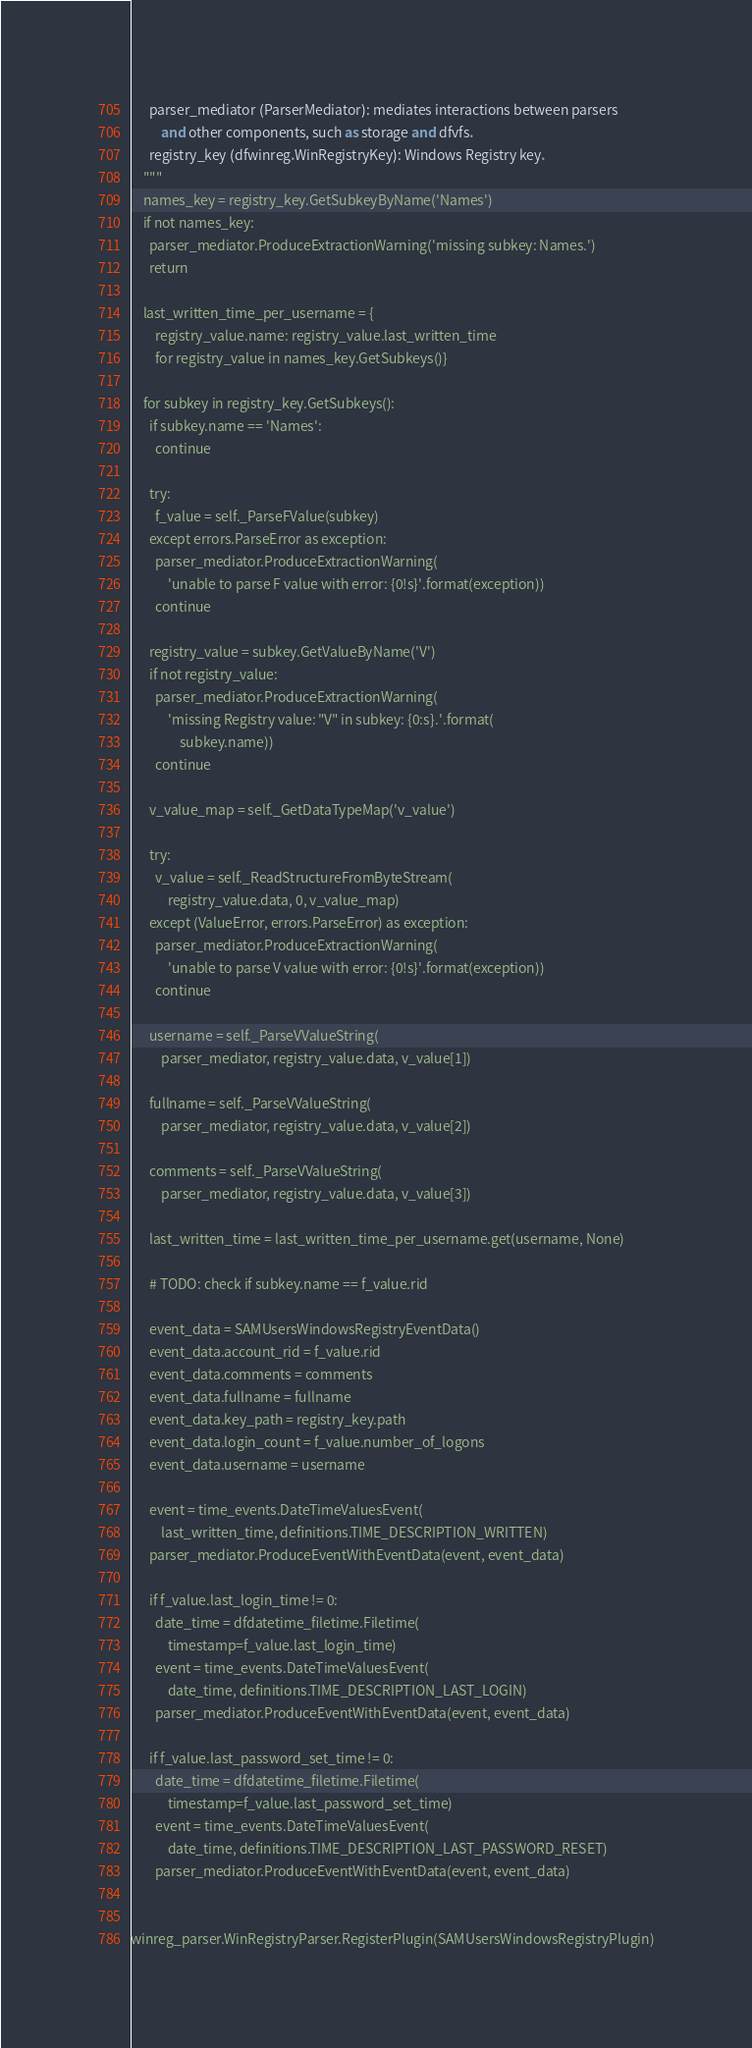<code> <loc_0><loc_0><loc_500><loc_500><_Python_>      parser_mediator (ParserMediator): mediates interactions between parsers
          and other components, such as storage and dfvfs.
      registry_key (dfwinreg.WinRegistryKey): Windows Registry key.
    """
    names_key = registry_key.GetSubkeyByName('Names')
    if not names_key:
      parser_mediator.ProduceExtractionWarning('missing subkey: Names.')
      return

    last_written_time_per_username = {
        registry_value.name: registry_value.last_written_time
        for registry_value in names_key.GetSubkeys()}

    for subkey in registry_key.GetSubkeys():
      if subkey.name == 'Names':
        continue

      try:
        f_value = self._ParseFValue(subkey)
      except errors.ParseError as exception:
        parser_mediator.ProduceExtractionWarning(
            'unable to parse F value with error: {0!s}'.format(exception))
        continue

      registry_value = subkey.GetValueByName('V')
      if not registry_value:
        parser_mediator.ProduceExtractionWarning(
            'missing Registry value: "V" in subkey: {0:s}.'.format(
                subkey.name))
        continue

      v_value_map = self._GetDataTypeMap('v_value')

      try:
        v_value = self._ReadStructureFromByteStream(
            registry_value.data, 0, v_value_map)
      except (ValueError, errors.ParseError) as exception:
        parser_mediator.ProduceExtractionWarning(
            'unable to parse V value with error: {0!s}'.format(exception))
        continue

      username = self._ParseVValueString(
          parser_mediator, registry_value.data, v_value[1])

      fullname = self._ParseVValueString(
          parser_mediator, registry_value.data, v_value[2])

      comments = self._ParseVValueString(
          parser_mediator, registry_value.data, v_value[3])

      last_written_time = last_written_time_per_username.get(username, None)

      # TODO: check if subkey.name == f_value.rid

      event_data = SAMUsersWindowsRegistryEventData()
      event_data.account_rid = f_value.rid
      event_data.comments = comments
      event_data.fullname = fullname
      event_data.key_path = registry_key.path
      event_data.login_count = f_value.number_of_logons
      event_data.username = username

      event = time_events.DateTimeValuesEvent(
          last_written_time, definitions.TIME_DESCRIPTION_WRITTEN)
      parser_mediator.ProduceEventWithEventData(event, event_data)

      if f_value.last_login_time != 0:
        date_time = dfdatetime_filetime.Filetime(
            timestamp=f_value.last_login_time)
        event = time_events.DateTimeValuesEvent(
            date_time, definitions.TIME_DESCRIPTION_LAST_LOGIN)
        parser_mediator.ProduceEventWithEventData(event, event_data)

      if f_value.last_password_set_time != 0:
        date_time = dfdatetime_filetime.Filetime(
            timestamp=f_value.last_password_set_time)
        event = time_events.DateTimeValuesEvent(
            date_time, definitions.TIME_DESCRIPTION_LAST_PASSWORD_RESET)
        parser_mediator.ProduceEventWithEventData(event, event_data)


winreg_parser.WinRegistryParser.RegisterPlugin(SAMUsersWindowsRegistryPlugin)
</code> 